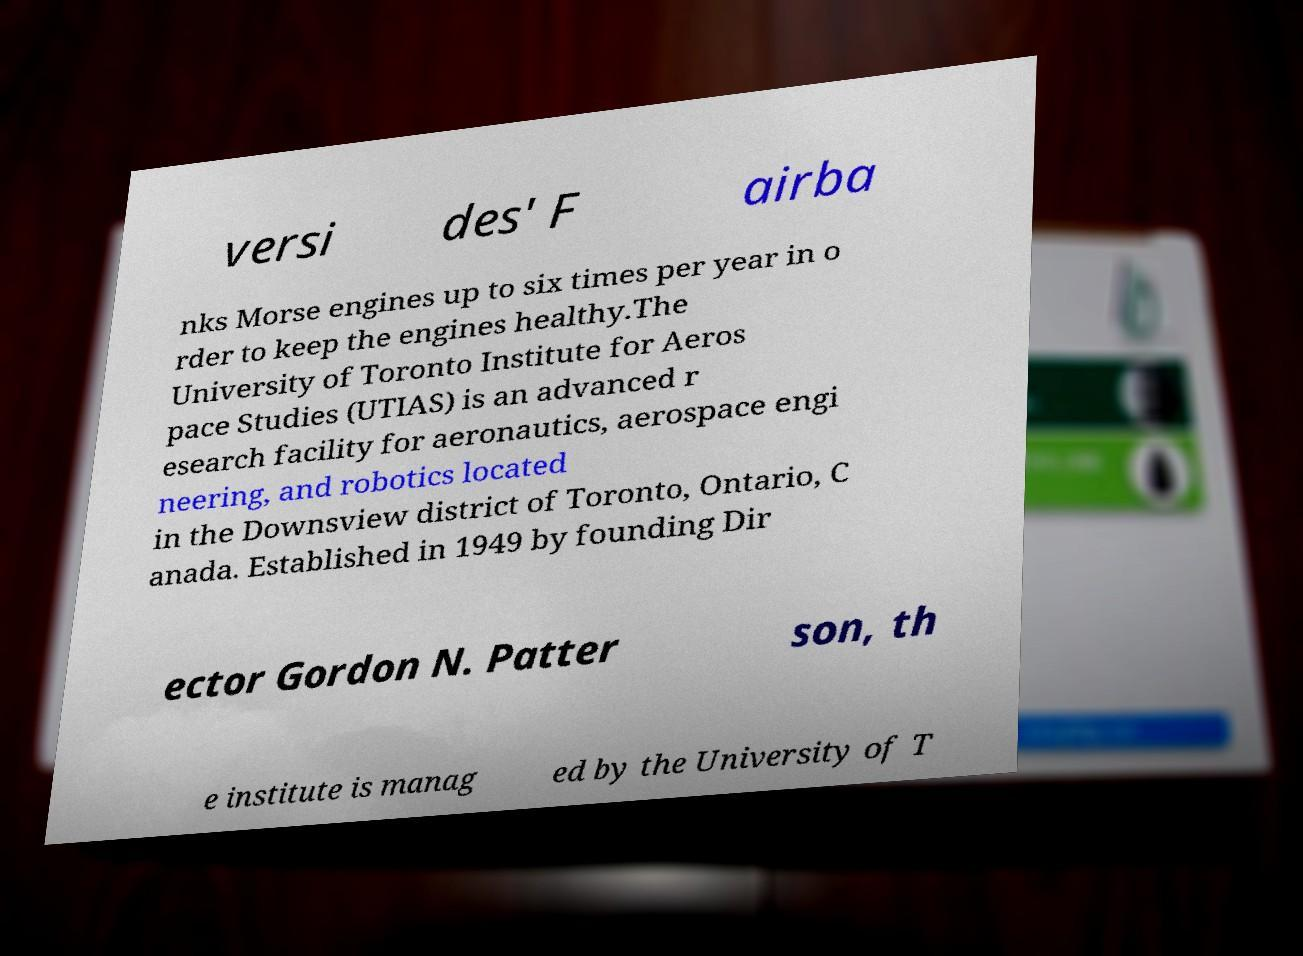What messages or text are displayed in this image? I need them in a readable, typed format. versi des' F airba nks Morse engines up to six times per year in o rder to keep the engines healthy.The University of Toronto Institute for Aeros pace Studies (UTIAS) is an advanced r esearch facility for aeronautics, aerospace engi neering, and robotics located in the Downsview district of Toronto, Ontario, C anada. Established in 1949 by founding Dir ector Gordon N. Patter son, th e institute is manag ed by the University of T 